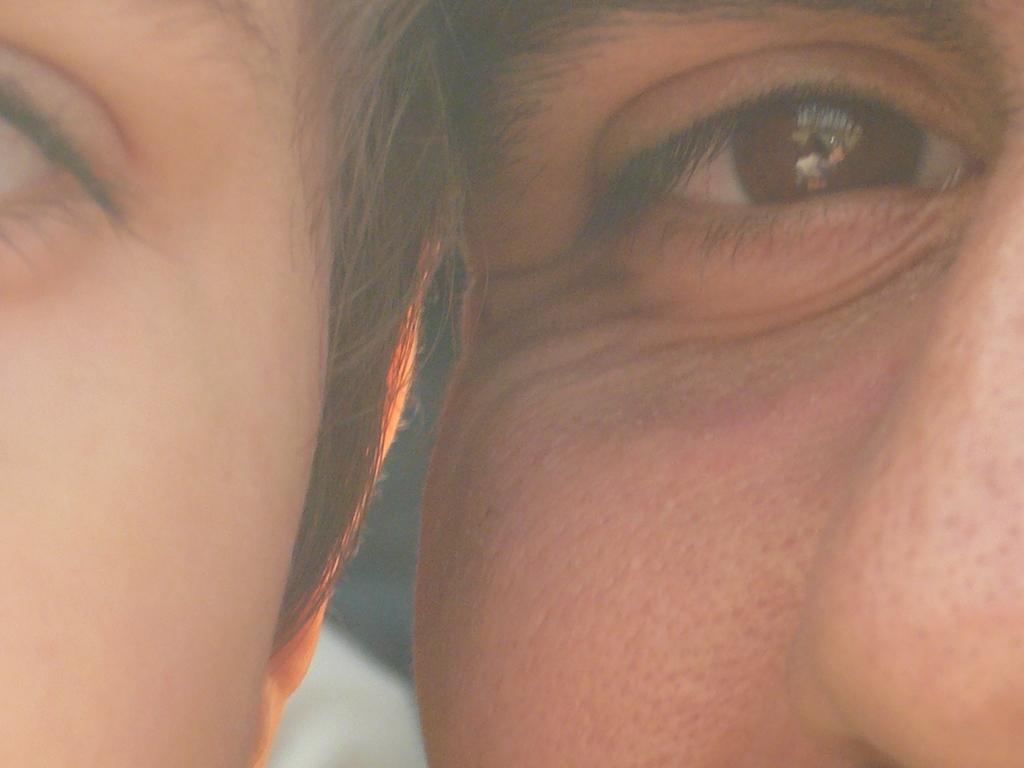Could you give a brief overview of what you see in this image? This image consists of 2 persons faces. One is one the left side, one is on the right side. Eyes are visible. 